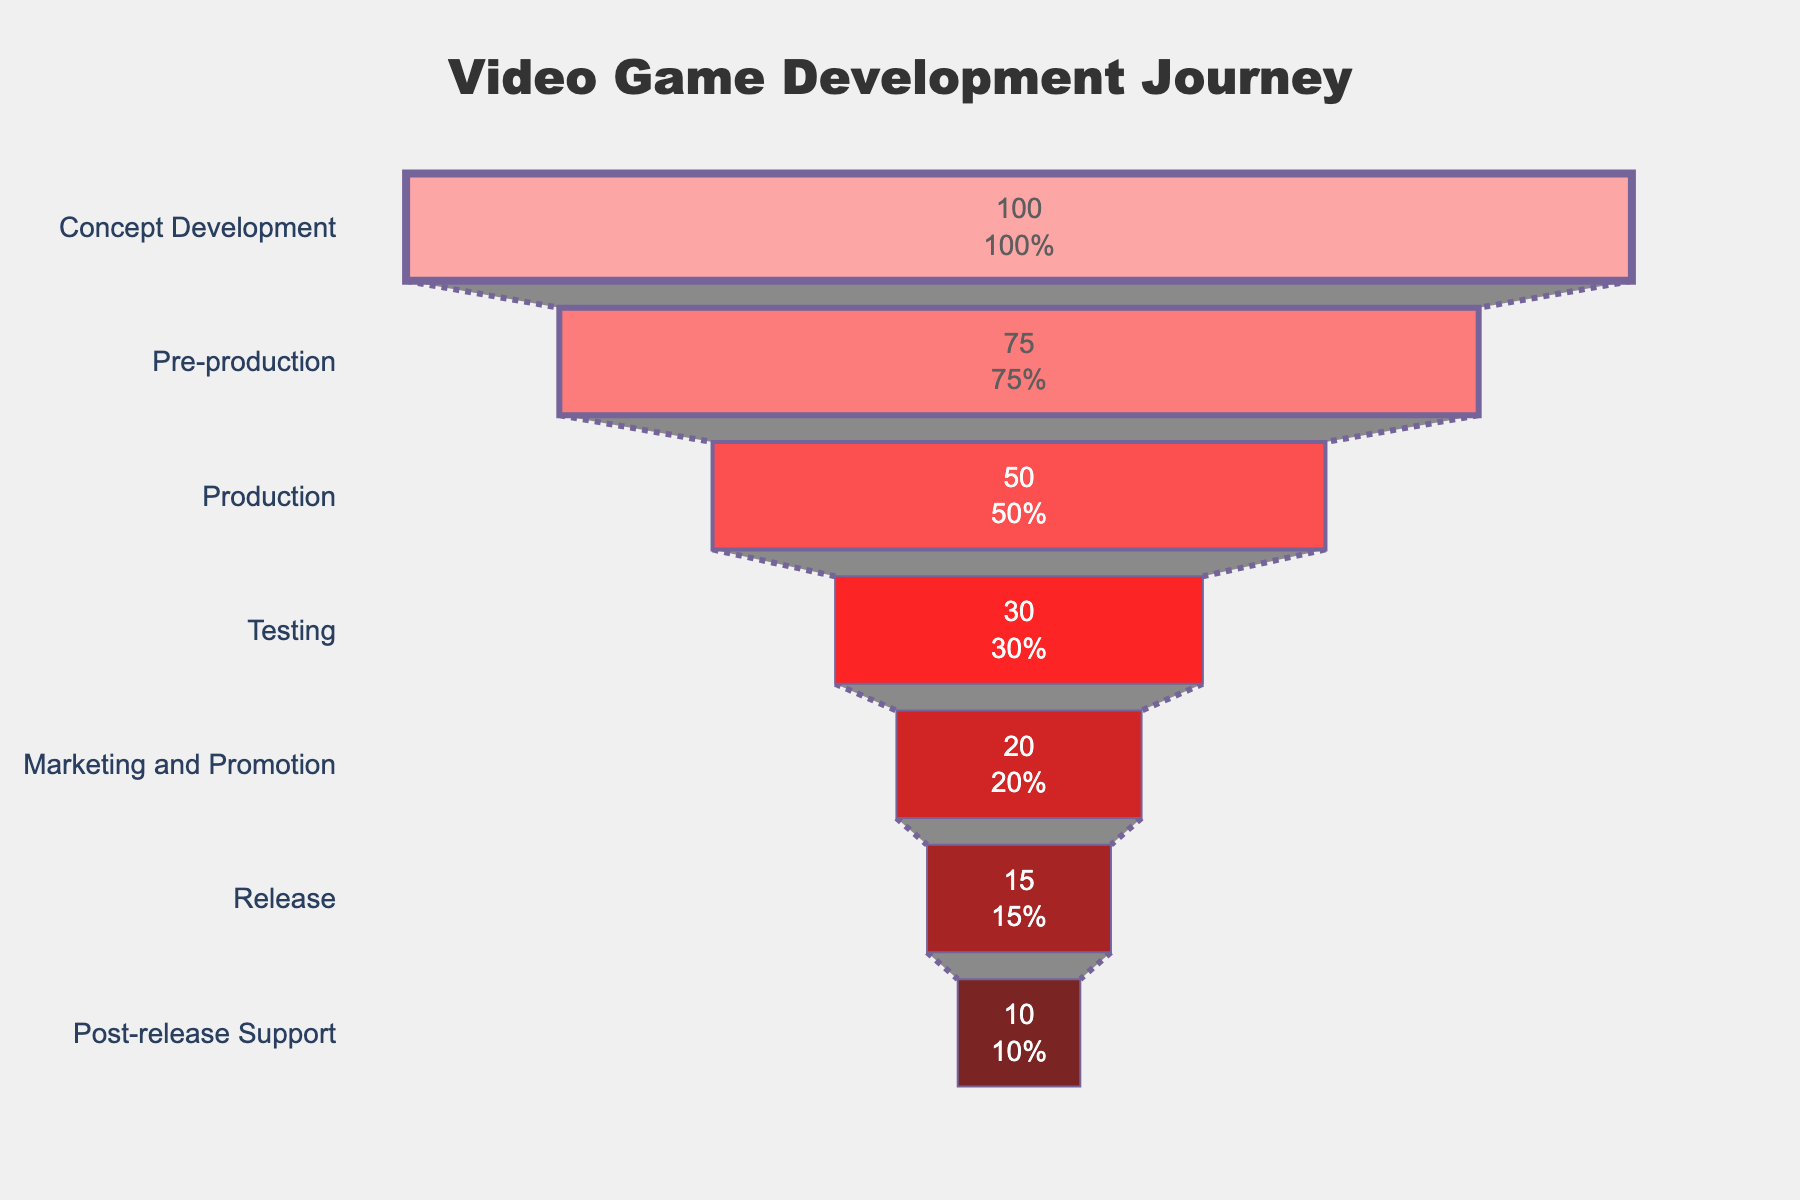what is the title of the chart? The title of the chart is usually located at the top and centered. It provides an overview of what the chart is about. In this case, the title is "Video Game Development Journey".
Answer: Video Game Development Journey How many games are in the Post-release Support stage? Look for the stage labeled "Post-release Support" and check the corresponding value in the funnel chart. The value is inside the section of the chart.
Answer: 10 Which stage has the highest number of games? Identify the stage with the largest section at the top of the funnel chart. It should have the highest value.
Answer: Concept Development What percentage of games progress from Testing to Marketing and Promotion? First, find the number of games in the Testing stage (30) and the number in the Marketing and Promotion stage (20). The percentage is calculated as (20/30) * 100%.
Answer: 66.67% How many total stages are shown in the funnel chart? Count the number of different sections (stages) in the funnel chart. Each stage is labeled with a unique name.
Answer: 7 If a game reaches the Release stage, what is the probability it will progress to Post-release Support? Find the number of games in the Release stage (15) and the number that progress to Post-release Support (10). The probability is calculated as 10/15.
Answer: 0.67 How many games do not make it past the Production stage? Find the number of games entering the Production stage (50) and the number entering the Testing stage (30). Subtract the latter from the former to find the number that do not progress.
Answer: 20 Which stage experienced the largest drop in the number of games from the previous stage? Examine the decrease in the number of games between each consecutive stage. The largest difference is between the Production (50) and Testing (30) stages.
Answer: Production to Testing What is the color of the section representing the Marketing and Promotion stage? Identify the color of the section in the funnel chart labeled "Marketing and Promotion".
Answer: Dark red 